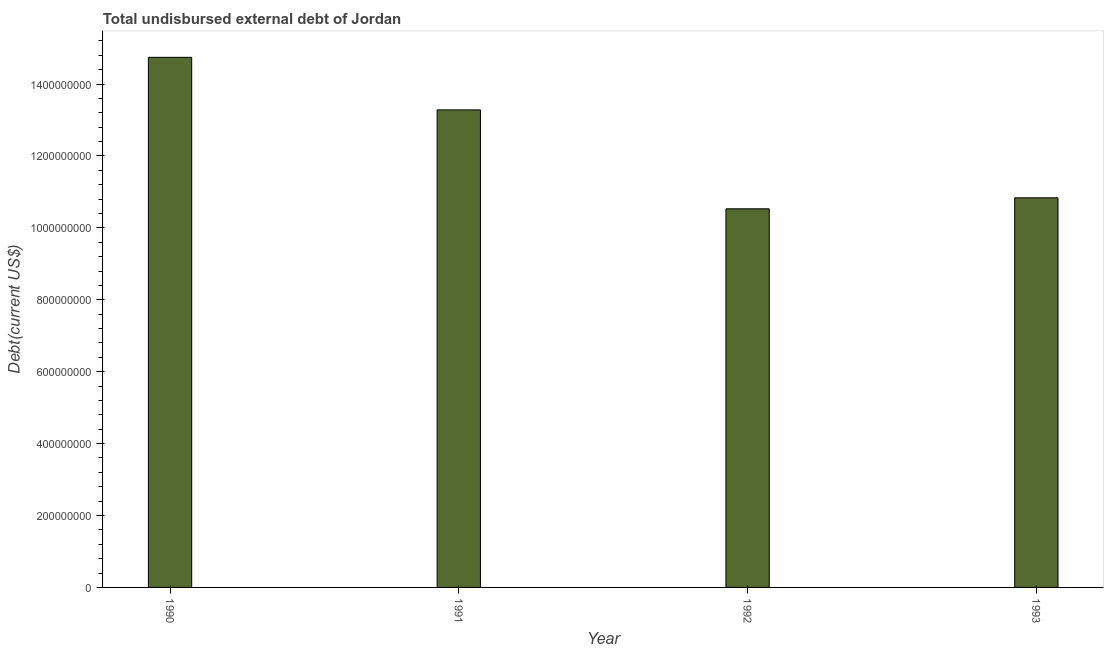Does the graph contain grids?
Your answer should be compact. No. What is the title of the graph?
Offer a very short reply. Total undisbursed external debt of Jordan. What is the label or title of the X-axis?
Make the answer very short. Year. What is the label or title of the Y-axis?
Ensure brevity in your answer.  Debt(current US$). What is the total debt in 1992?
Provide a short and direct response. 1.05e+09. Across all years, what is the maximum total debt?
Ensure brevity in your answer.  1.47e+09. Across all years, what is the minimum total debt?
Keep it short and to the point. 1.05e+09. What is the sum of the total debt?
Keep it short and to the point. 4.94e+09. What is the difference between the total debt in 1991 and 1992?
Provide a succinct answer. 2.75e+08. What is the average total debt per year?
Provide a succinct answer. 1.23e+09. What is the median total debt?
Ensure brevity in your answer.  1.21e+09. In how many years, is the total debt greater than 520000000 US$?
Provide a short and direct response. 4. Do a majority of the years between 1990 and 1993 (inclusive) have total debt greater than 320000000 US$?
Provide a short and direct response. Yes. What is the ratio of the total debt in 1991 to that in 1992?
Offer a terse response. 1.26. Is the difference between the total debt in 1991 and 1992 greater than the difference between any two years?
Offer a very short reply. No. What is the difference between the highest and the second highest total debt?
Ensure brevity in your answer.  1.46e+08. Is the sum of the total debt in 1991 and 1992 greater than the maximum total debt across all years?
Your answer should be compact. Yes. What is the difference between the highest and the lowest total debt?
Offer a very short reply. 4.21e+08. In how many years, is the total debt greater than the average total debt taken over all years?
Your answer should be very brief. 2. Are the values on the major ticks of Y-axis written in scientific E-notation?
Your answer should be compact. No. What is the Debt(current US$) in 1990?
Offer a very short reply. 1.47e+09. What is the Debt(current US$) of 1991?
Provide a succinct answer. 1.33e+09. What is the Debt(current US$) of 1992?
Offer a terse response. 1.05e+09. What is the Debt(current US$) in 1993?
Keep it short and to the point. 1.08e+09. What is the difference between the Debt(current US$) in 1990 and 1991?
Offer a terse response. 1.46e+08. What is the difference between the Debt(current US$) in 1990 and 1992?
Give a very brief answer. 4.21e+08. What is the difference between the Debt(current US$) in 1990 and 1993?
Offer a very short reply. 3.91e+08. What is the difference between the Debt(current US$) in 1991 and 1992?
Offer a very short reply. 2.75e+08. What is the difference between the Debt(current US$) in 1991 and 1993?
Keep it short and to the point. 2.45e+08. What is the difference between the Debt(current US$) in 1992 and 1993?
Your response must be concise. -3.06e+07. What is the ratio of the Debt(current US$) in 1990 to that in 1991?
Your answer should be compact. 1.11. What is the ratio of the Debt(current US$) in 1990 to that in 1992?
Your answer should be compact. 1.4. What is the ratio of the Debt(current US$) in 1990 to that in 1993?
Provide a succinct answer. 1.36. What is the ratio of the Debt(current US$) in 1991 to that in 1992?
Make the answer very short. 1.26. What is the ratio of the Debt(current US$) in 1991 to that in 1993?
Your response must be concise. 1.23. 